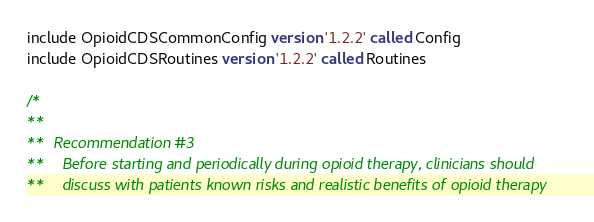Convert code to text. <code><loc_0><loc_0><loc_500><loc_500><_SQL_>include OpioidCDSCommonConfig version '1.2.2' called Config
include OpioidCDSRoutines version '1.2.2' called Routines

/*
**
**  Recommendation #3
**    Before starting and periodically during opioid therapy, clinicians should
**    discuss with patients known risks and realistic benefits of opioid therapy</code> 